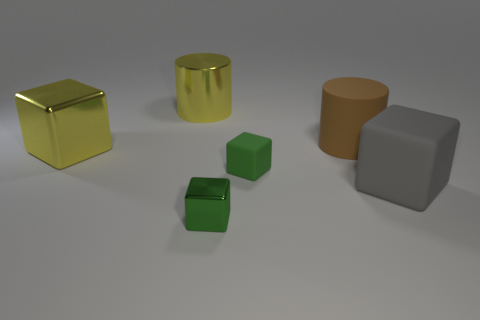Subtract all brown cylinders. Subtract all cyan balls. How many cylinders are left? 1 Add 1 large brown things. How many objects exist? 7 Subtract all blocks. How many objects are left? 2 Subtract 1 green blocks. How many objects are left? 5 Subtract all big gray rubber cubes. Subtract all big brown objects. How many objects are left? 4 Add 3 rubber objects. How many rubber objects are left? 6 Add 3 matte cylinders. How many matte cylinders exist? 4 